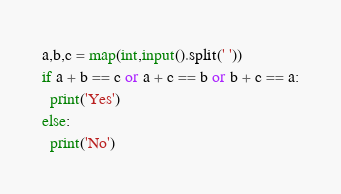Convert code to text. <code><loc_0><loc_0><loc_500><loc_500><_Python_>a,b,c = map(int,input().split(' '))
if a + b == c or a + c == b or b + c == a:
  print('Yes')
else:
  print('No')</code> 